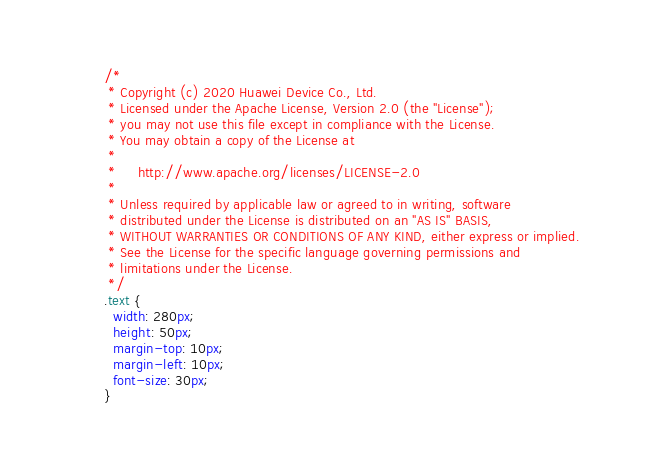<code> <loc_0><loc_0><loc_500><loc_500><_CSS_>/*
 * Copyright (c) 2020 Huawei Device Co., Ltd.
 * Licensed under the Apache License, Version 2.0 (the "License");
 * you may not use this file except in compliance with the License.
 * You may obtain a copy of the License at
 *
 *     http://www.apache.org/licenses/LICENSE-2.0
 *
 * Unless required by applicable law or agreed to in writing, software
 * distributed under the License is distributed on an "AS IS" BASIS,
 * WITHOUT WARRANTIES OR CONDITIONS OF ANY KIND, either express or implied.
 * See the License for the specific language governing permissions and
 * limitations under the License.
 */
.text {
  width: 280px;
  height: 50px;
  margin-top: 10px;
  margin-left: 10px;
  font-size: 30px;
}
</code> 